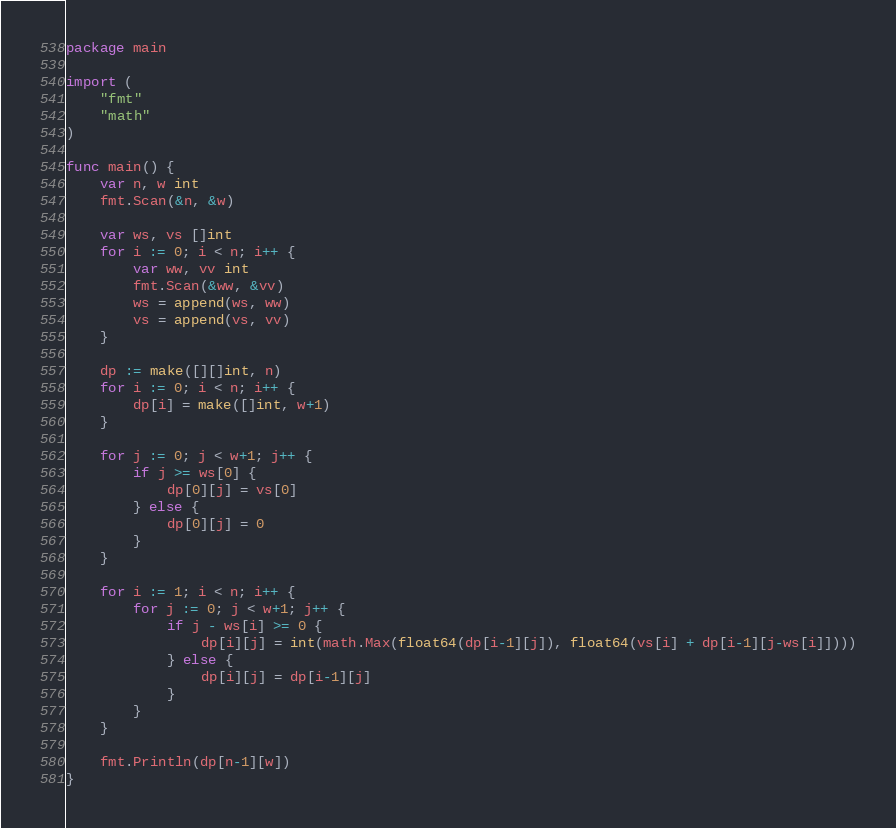Convert code to text. <code><loc_0><loc_0><loc_500><loc_500><_Go_>package main

import (
	"fmt"
	"math"
)

func main() {
	var n, w int
	fmt.Scan(&n, &w)

	var ws, vs []int
	for i := 0; i < n; i++ {
		var ww, vv int
		fmt.Scan(&ww, &vv)
		ws = append(ws, ww)
		vs = append(vs, vv)
	}

	dp := make([][]int, n)
	for i := 0; i < n; i++ {
		dp[i] = make([]int, w+1)
	}

	for j := 0; j < w+1; j++ {
		if j >= ws[0] {
			dp[0][j] = vs[0]
		} else {
			dp[0][j] = 0
		}
	}

	for i := 1; i < n; i++ {
		for j := 0; j < w+1; j++ {
			if j - ws[i] >= 0 {
				dp[i][j] = int(math.Max(float64(dp[i-1][j]), float64(vs[i] + dp[i-1][j-ws[i]])))
			} else {
				dp[i][j] = dp[i-1][j]
			}
		}
	}

	fmt.Println(dp[n-1][w])
}</code> 